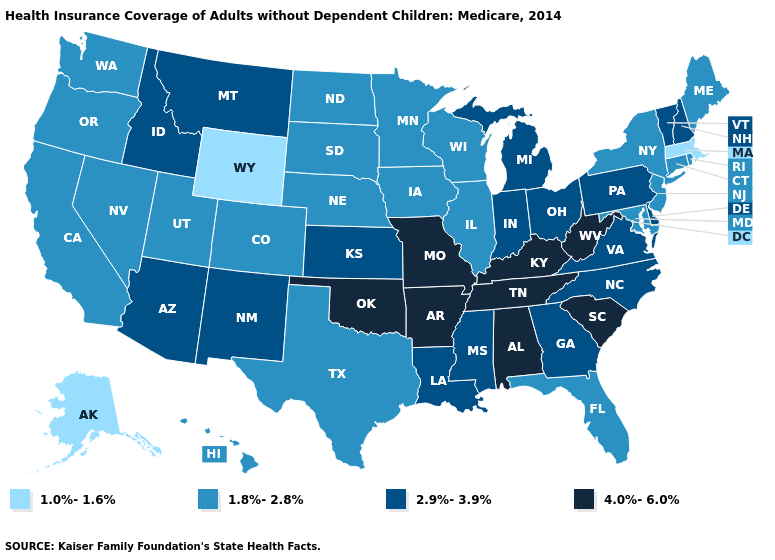Among the states that border Nevada , which have the highest value?
Short answer required. Arizona, Idaho. Name the states that have a value in the range 1.0%-1.6%?
Write a very short answer. Alaska, Massachusetts, Wyoming. What is the highest value in the USA?
Answer briefly. 4.0%-6.0%. What is the value of Oklahoma?
Short answer required. 4.0%-6.0%. Name the states that have a value in the range 1.8%-2.8%?
Concise answer only. California, Colorado, Connecticut, Florida, Hawaii, Illinois, Iowa, Maine, Maryland, Minnesota, Nebraska, Nevada, New Jersey, New York, North Dakota, Oregon, Rhode Island, South Dakota, Texas, Utah, Washington, Wisconsin. What is the value of New Jersey?
Give a very brief answer. 1.8%-2.8%. What is the value of Oklahoma?
Write a very short answer. 4.0%-6.0%. What is the highest value in states that border Kansas?
Answer briefly. 4.0%-6.0%. Name the states that have a value in the range 4.0%-6.0%?
Concise answer only. Alabama, Arkansas, Kentucky, Missouri, Oklahoma, South Carolina, Tennessee, West Virginia. What is the value of Illinois?
Concise answer only. 1.8%-2.8%. What is the value of California?
Give a very brief answer. 1.8%-2.8%. What is the value of North Carolina?
Concise answer only. 2.9%-3.9%. Name the states that have a value in the range 1.8%-2.8%?
Write a very short answer. California, Colorado, Connecticut, Florida, Hawaii, Illinois, Iowa, Maine, Maryland, Minnesota, Nebraska, Nevada, New Jersey, New York, North Dakota, Oregon, Rhode Island, South Dakota, Texas, Utah, Washington, Wisconsin. Name the states that have a value in the range 2.9%-3.9%?
Give a very brief answer. Arizona, Delaware, Georgia, Idaho, Indiana, Kansas, Louisiana, Michigan, Mississippi, Montana, New Hampshire, New Mexico, North Carolina, Ohio, Pennsylvania, Vermont, Virginia. Which states have the highest value in the USA?
Be succinct. Alabama, Arkansas, Kentucky, Missouri, Oklahoma, South Carolina, Tennessee, West Virginia. 